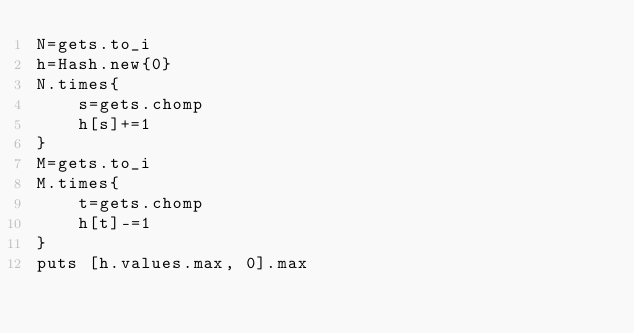<code> <loc_0><loc_0><loc_500><loc_500><_Ruby_>N=gets.to_i
h=Hash.new{0}
N.times{
    s=gets.chomp
    h[s]+=1
}
M=gets.to_i
M.times{
    t=gets.chomp
    h[t]-=1
}
puts [h.values.max, 0].max
</code> 